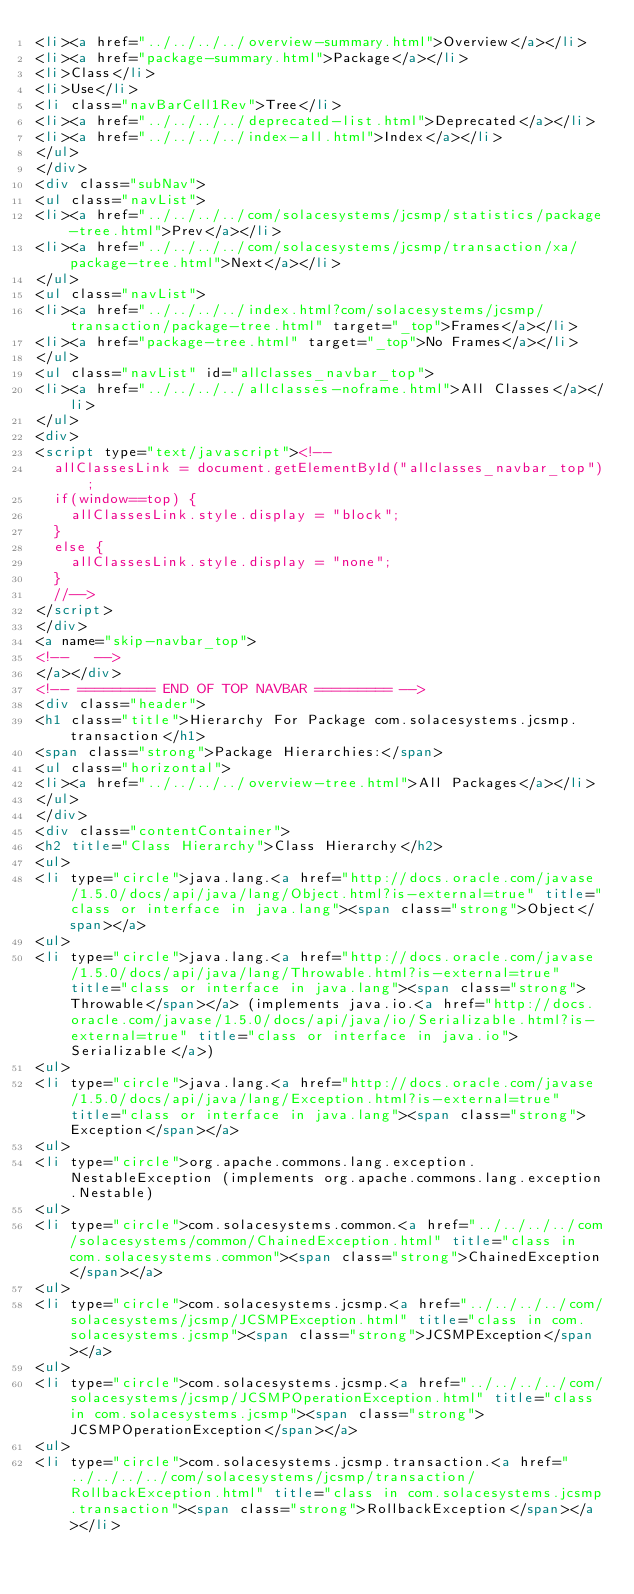<code> <loc_0><loc_0><loc_500><loc_500><_HTML_><li><a href="../../../../overview-summary.html">Overview</a></li>
<li><a href="package-summary.html">Package</a></li>
<li>Class</li>
<li>Use</li>
<li class="navBarCell1Rev">Tree</li>
<li><a href="../../../../deprecated-list.html">Deprecated</a></li>
<li><a href="../../../../index-all.html">Index</a></li>
</ul>
</div>
<div class="subNav">
<ul class="navList">
<li><a href="../../../../com/solacesystems/jcsmp/statistics/package-tree.html">Prev</a></li>
<li><a href="../../../../com/solacesystems/jcsmp/transaction/xa/package-tree.html">Next</a></li>
</ul>
<ul class="navList">
<li><a href="../../../../index.html?com/solacesystems/jcsmp/transaction/package-tree.html" target="_top">Frames</a></li>
<li><a href="package-tree.html" target="_top">No Frames</a></li>
</ul>
<ul class="navList" id="allclasses_navbar_top">
<li><a href="../../../../allclasses-noframe.html">All Classes</a></li>
</ul>
<div>
<script type="text/javascript"><!--
  allClassesLink = document.getElementById("allclasses_navbar_top");
  if(window==top) {
    allClassesLink.style.display = "block";
  }
  else {
    allClassesLink.style.display = "none";
  }
  //-->
</script>
</div>
<a name="skip-navbar_top">
<!--   -->
</a></div>
<!-- ========= END OF TOP NAVBAR ========= -->
<div class="header">
<h1 class="title">Hierarchy For Package com.solacesystems.jcsmp.transaction</h1>
<span class="strong">Package Hierarchies:</span>
<ul class="horizontal">
<li><a href="../../../../overview-tree.html">All Packages</a></li>
</ul>
</div>
<div class="contentContainer">
<h2 title="Class Hierarchy">Class Hierarchy</h2>
<ul>
<li type="circle">java.lang.<a href="http://docs.oracle.com/javase/1.5.0/docs/api/java/lang/Object.html?is-external=true" title="class or interface in java.lang"><span class="strong">Object</span></a>
<ul>
<li type="circle">java.lang.<a href="http://docs.oracle.com/javase/1.5.0/docs/api/java/lang/Throwable.html?is-external=true" title="class or interface in java.lang"><span class="strong">Throwable</span></a> (implements java.io.<a href="http://docs.oracle.com/javase/1.5.0/docs/api/java/io/Serializable.html?is-external=true" title="class or interface in java.io">Serializable</a>)
<ul>
<li type="circle">java.lang.<a href="http://docs.oracle.com/javase/1.5.0/docs/api/java/lang/Exception.html?is-external=true" title="class or interface in java.lang"><span class="strong">Exception</span></a>
<ul>
<li type="circle">org.apache.commons.lang.exception.NestableException (implements org.apache.commons.lang.exception.Nestable)
<ul>
<li type="circle">com.solacesystems.common.<a href="../../../../com/solacesystems/common/ChainedException.html" title="class in com.solacesystems.common"><span class="strong">ChainedException</span></a>
<ul>
<li type="circle">com.solacesystems.jcsmp.<a href="../../../../com/solacesystems/jcsmp/JCSMPException.html" title="class in com.solacesystems.jcsmp"><span class="strong">JCSMPException</span></a>
<ul>
<li type="circle">com.solacesystems.jcsmp.<a href="../../../../com/solacesystems/jcsmp/JCSMPOperationException.html" title="class in com.solacesystems.jcsmp"><span class="strong">JCSMPOperationException</span></a>
<ul>
<li type="circle">com.solacesystems.jcsmp.transaction.<a href="../../../../com/solacesystems/jcsmp/transaction/RollbackException.html" title="class in com.solacesystems.jcsmp.transaction"><span class="strong">RollbackException</span></a></li></code> 